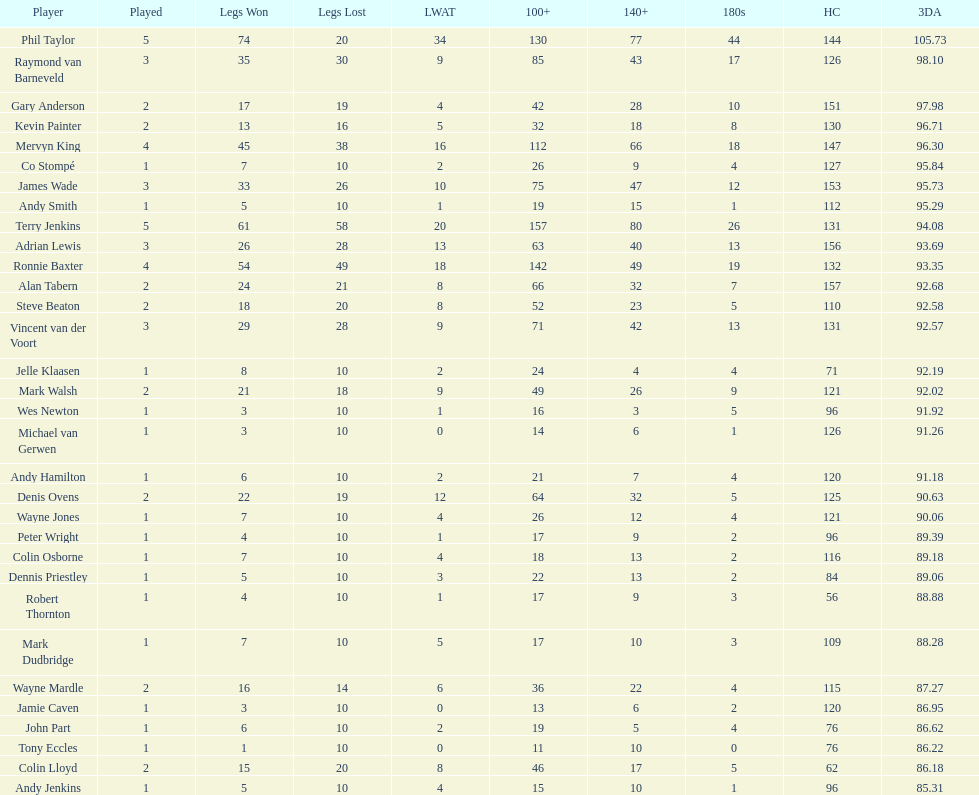What were the total number of legs won by ronnie baxter? 54. 